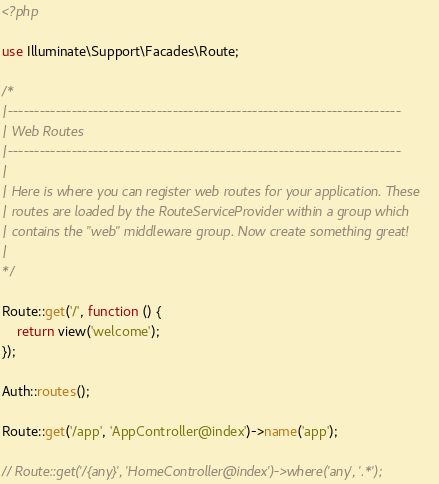<code> <loc_0><loc_0><loc_500><loc_500><_PHP_><?php

use Illuminate\Support\Facades\Route;

/*
|--------------------------------------------------------------------------
| Web Routes
|--------------------------------------------------------------------------
|
| Here is where you can register web routes for your application. These
| routes are loaded by the RouteServiceProvider within a group which
| contains the "web" middleware group. Now create something great!
|
*/

Route::get('/', function () {
    return view('welcome');
});

Auth::routes();

Route::get('/app', 'AppController@index')->name('app');

// Route::get('/{any}', 'HomeController@index')->where('any', '.*');</code> 